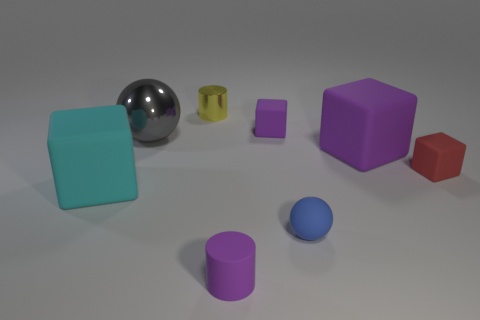There is a big rubber thing to the left of the rubber cylinder; is its shape the same as the big purple object on the right side of the tiny sphere?
Give a very brief answer. Yes. How many spheres are yellow objects or gray metallic things?
Provide a short and direct response. 1. Is the material of the small sphere the same as the purple cylinder?
Offer a terse response. Yes. What number of other objects are there of the same color as the rubber sphere?
Ensure brevity in your answer.  0. What shape is the large matte thing that is to the left of the yellow metallic object?
Offer a terse response. Cube. What number of things are either blue rubber things or large blue metallic things?
Make the answer very short. 1. Does the purple rubber cylinder have the same size as the purple cube left of the small rubber ball?
Provide a short and direct response. Yes. What number of other things are there of the same material as the red block
Make the answer very short. 5. How many objects are things behind the cyan cube or large blocks that are to the left of the purple cylinder?
Make the answer very short. 6. What is the material of the other big object that is the same shape as the blue thing?
Make the answer very short. Metal. 